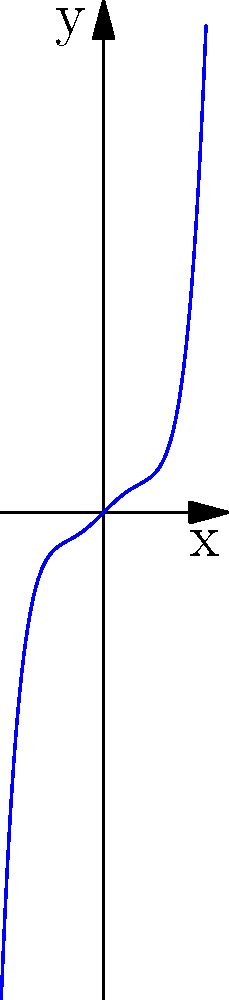As a startup owner looking to increase site traffic, you're analyzing the growth patterns of your website visitors over time. The graph above represents a polynomial function modeling your site's traffic growth. Based on the end behavior of this higher-degree polynomial graph, what can you conclude about the long-term trend of your website's traffic? To analyze the end behavior of this polynomial graph, we need to follow these steps:

1. Identify the degree of the polynomial:
   The highest power of x in the function is 5, so this is a 5th-degree polynomial.

2. Determine the sign of the leading coefficient:
   The coefficient of x^5 is positive (0.01).

3. Apply the end behavior rule for odd-degree polynomials:
   For odd-degree polynomials with a positive leading coefficient:
   - As x approaches positive infinity, y approaches positive infinity.
   - As x approaches negative infinity, y approaches negative infinity.

4. Interpret the graph:
   The graph clearly shows that as x increases (moves right), y increases rapidly.
   As x decreases (moves left), y decreases rapidly.

5. Relate to website traffic:
   In this context, x represents time, and y represents website traffic.
   The end behavior suggests that as time progresses (x increases), the website traffic (y) will continue to grow at an increasing rate.

Therefore, based on this model, we can conclude that the long-term trend of the website's traffic shows exponential growth, with traffic increasing at an accelerating rate over time.
Answer: Exponential growth in long-term website traffic 